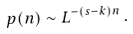Convert formula to latex. <formula><loc_0><loc_0><loc_500><loc_500>p ( n ) \sim L ^ { - ( s - k ) n } \, .</formula> 